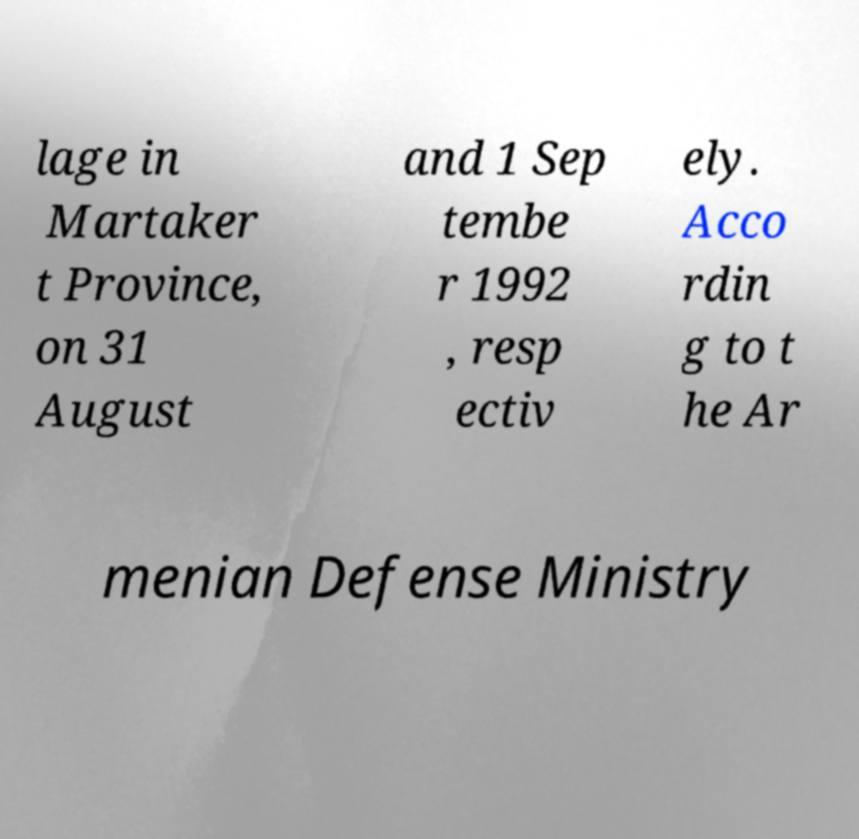For documentation purposes, I need the text within this image transcribed. Could you provide that? lage in Martaker t Province, on 31 August and 1 Sep tembe r 1992 , resp ectiv ely. Acco rdin g to t he Ar menian Defense Ministry 